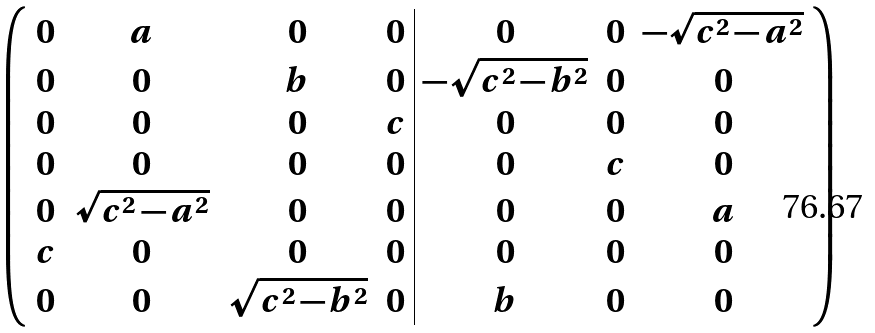Convert formula to latex. <formula><loc_0><loc_0><loc_500><loc_500>\left ( \begin{array} { c c c c | c c c } 0 & a & 0 & 0 & 0 & 0 & - \sqrt { c ^ { 2 } - a ^ { 2 } } \\ 0 & 0 & b & 0 & - \sqrt { c ^ { 2 } - b ^ { 2 } } & 0 & 0 \\ 0 & 0 & 0 & c & 0 & 0 & 0 \\ 0 & 0 & 0 & 0 & 0 & c & 0 \\ 0 & \sqrt { c ^ { 2 } - a ^ { 2 } } & 0 & 0 & 0 & 0 & a \\ c & 0 & 0 & 0 & 0 & 0 & 0 \\ 0 & 0 & \sqrt { c ^ { 2 } - b ^ { 2 } } & 0 & b & 0 & 0 \end{array} \right )</formula> 